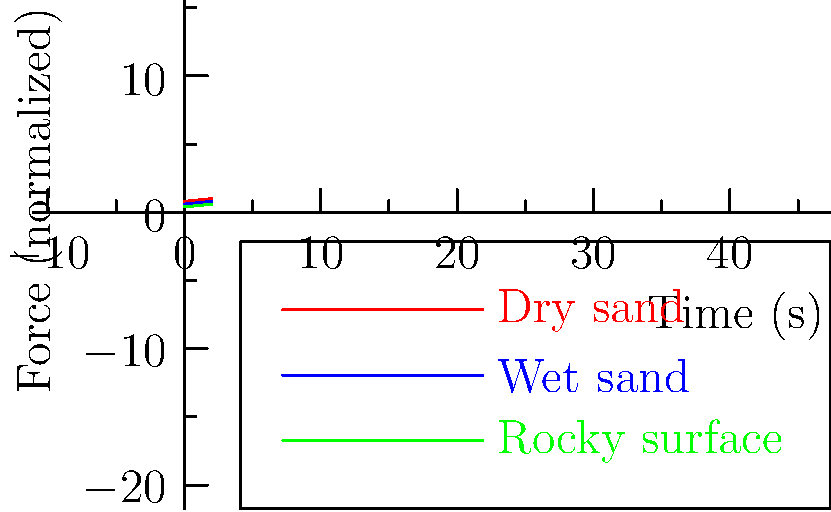As a travel blogger recommending activities for seniors in Hawaii, you need to understand the impact of different beach surfaces on walking. The graph shows the normalized force acting on feet when walking on various beach surfaces over time. Which surface provides the most stable and consistent force distribution, potentially being the safest option for senior travelers? To determine the safest beach surface for senior travelers, we need to analyze the force distribution patterns shown in the graph:

1. Dry sand (red line):
   - Shows the highest overall force
   - Has the most significant variations in force over time
   - This indicates an unstable surface that requires more effort to walk on

2. Wet sand (blue line):
   - Displays a moderate level of force
   - Shows some variations, but less than dry sand
   - Offers a more stable surface than dry sand

3. Rocky surface (green line):
   - Exhibits the lowest overall force
   - Shows the least variation in force over time
   - Indicates a more consistent and stable surface

For senior travelers, the ideal surface would be one that:
a) Requires less effort (lower force)
b) Provides more stability (less variation in force)

Based on these criteria, the rocky surface (green line) appears to be the safest option as it offers:
- The lowest overall force, requiring less effort to walk on
- The most consistent force distribution, providing better stability

While rocky surfaces might seem counterintuitive for safety, in this context, they likely represent a compact, even surface rather than large, loose rocks. This could be similar to a pebble beach or a well-maintained walking path near the shore.
Answer: Rocky surface 